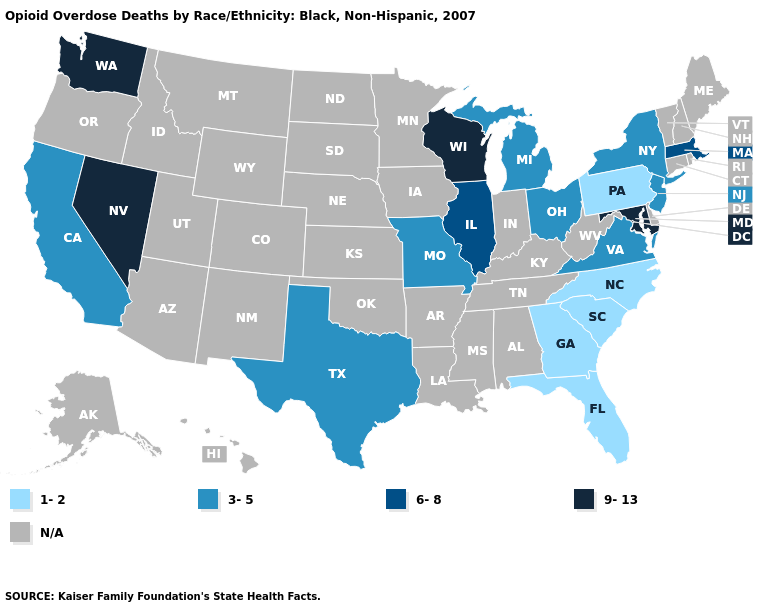What is the lowest value in the South?
Answer briefly. 1-2. Name the states that have a value in the range 1-2?
Answer briefly. Florida, Georgia, North Carolina, Pennsylvania, South Carolina. Name the states that have a value in the range 3-5?
Give a very brief answer. California, Michigan, Missouri, New Jersey, New York, Ohio, Texas, Virginia. What is the value of Rhode Island?
Write a very short answer. N/A. What is the highest value in the Northeast ?
Answer briefly. 6-8. Name the states that have a value in the range 1-2?
Give a very brief answer. Florida, Georgia, North Carolina, Pennsylvania, South Carolina. Name the states that have a value in the range 1-2?
Be succinct. Florida, Georgia, North Carolina, Pennsylvania, South Carolina. Name the states that have a value in the range 9-13?
Be succinct. Maryland, Nevada, Washington, Wisconsin. Which states have the lowest value in the USA?
Concise answer only. Florida, Georgia, North Carolina, Pennsylvania, South Carolina. Name the states that have a value in the range 3-5?
Short answer required. California, Michigan, Missouri, New Jersey, New York, Ohio, Texas, Virginia. What is the value of Arkansas?
Quick response, please. N/A. What is the lowest value in the USA?
Be succinct. 1-2. What is the value of North Carolina?
Give a very brief answer. 1-2. 